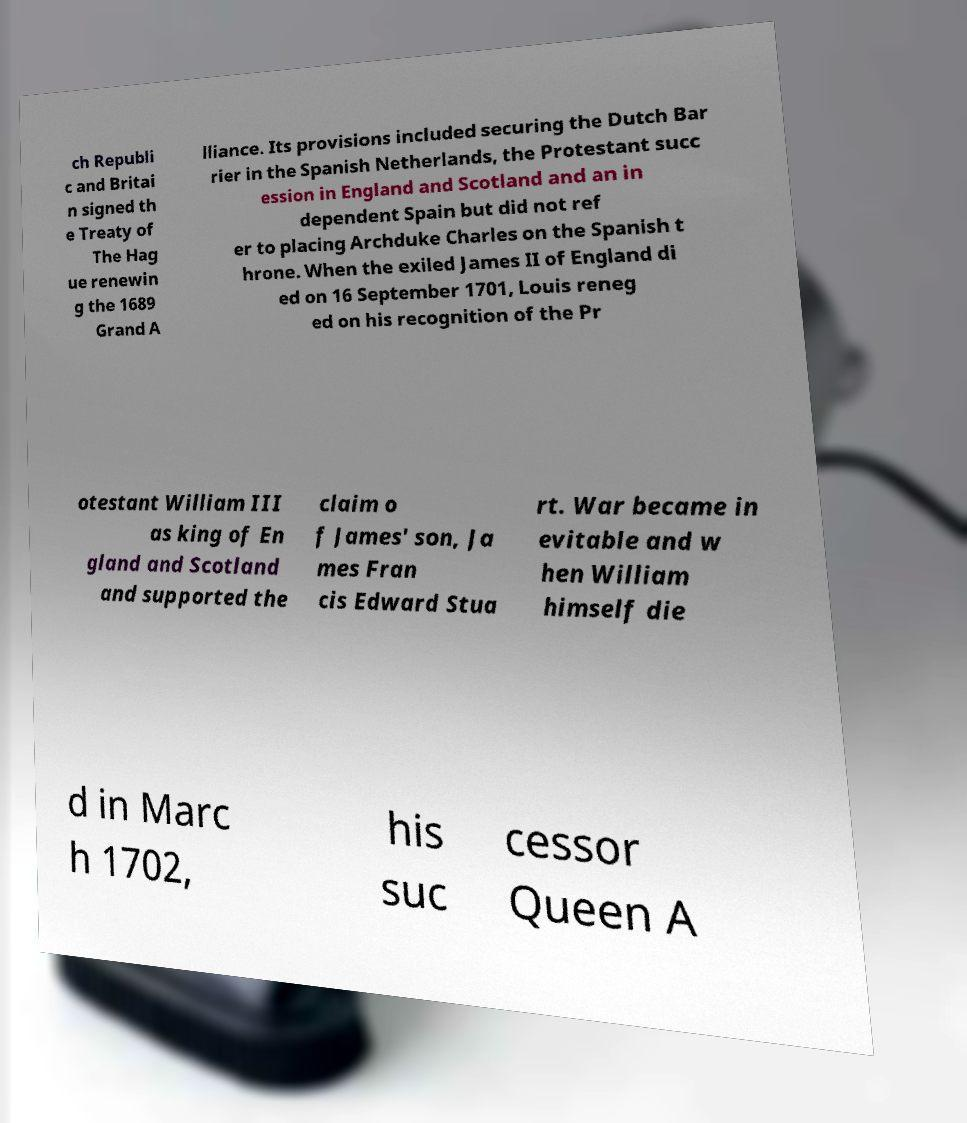I need the written content from this picture converted into text. Can you do that? ch Republi c and Britai n signed th e Treaty of The Hag ue renewin g the 1689 Grand A lliance. Its provisions included securing the Dutch Bar rier in the Spanish Netherlands, the Protestant succ ession in England and Scotland and an in dependent Spain but did not ref er to placing Archduke Charles on the Spanish t hrone. When the exiled James II of England di ed on 16 September 1701, Louis reneg ed on his recognition of the Pr otestant William III as king of En gland and Scotland and supported the claim o f James' son, Ja mes Fran cis Edward Stua rt. War became in evitable and w hen William himself die d in Marc h 1702, his suc cessor Queen A 